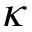Convert formula to latex. <formula><loc_0><loc_0><loc_500><loc_500>\kappa</formula> 